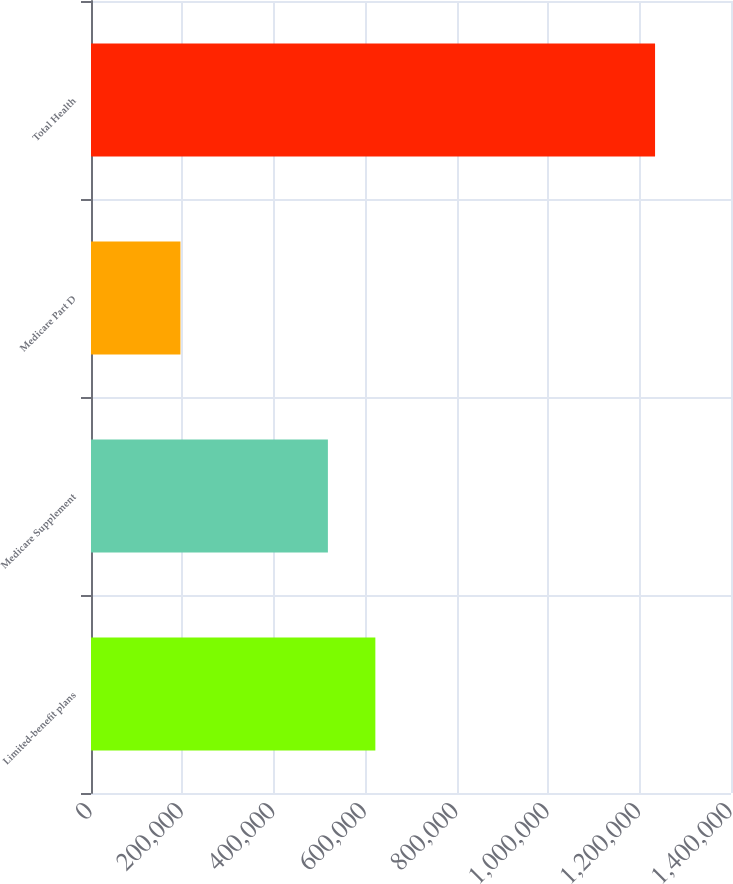<chart> <loc_0><loc_0><loc_500><loc_500><bar_chart><fcel>Limited-benefit plans<fcel>Medicare Supplement<fcel>Medicare Part D<fcel>Total Health<nl><fcel>622025<fcel>518205<fcel>195685<fcel>1.23388e+06<nl></chart> 